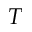Convert formula to latex. <formula><loc_0><loc_0><loc_500><loc_500>T</formula> 